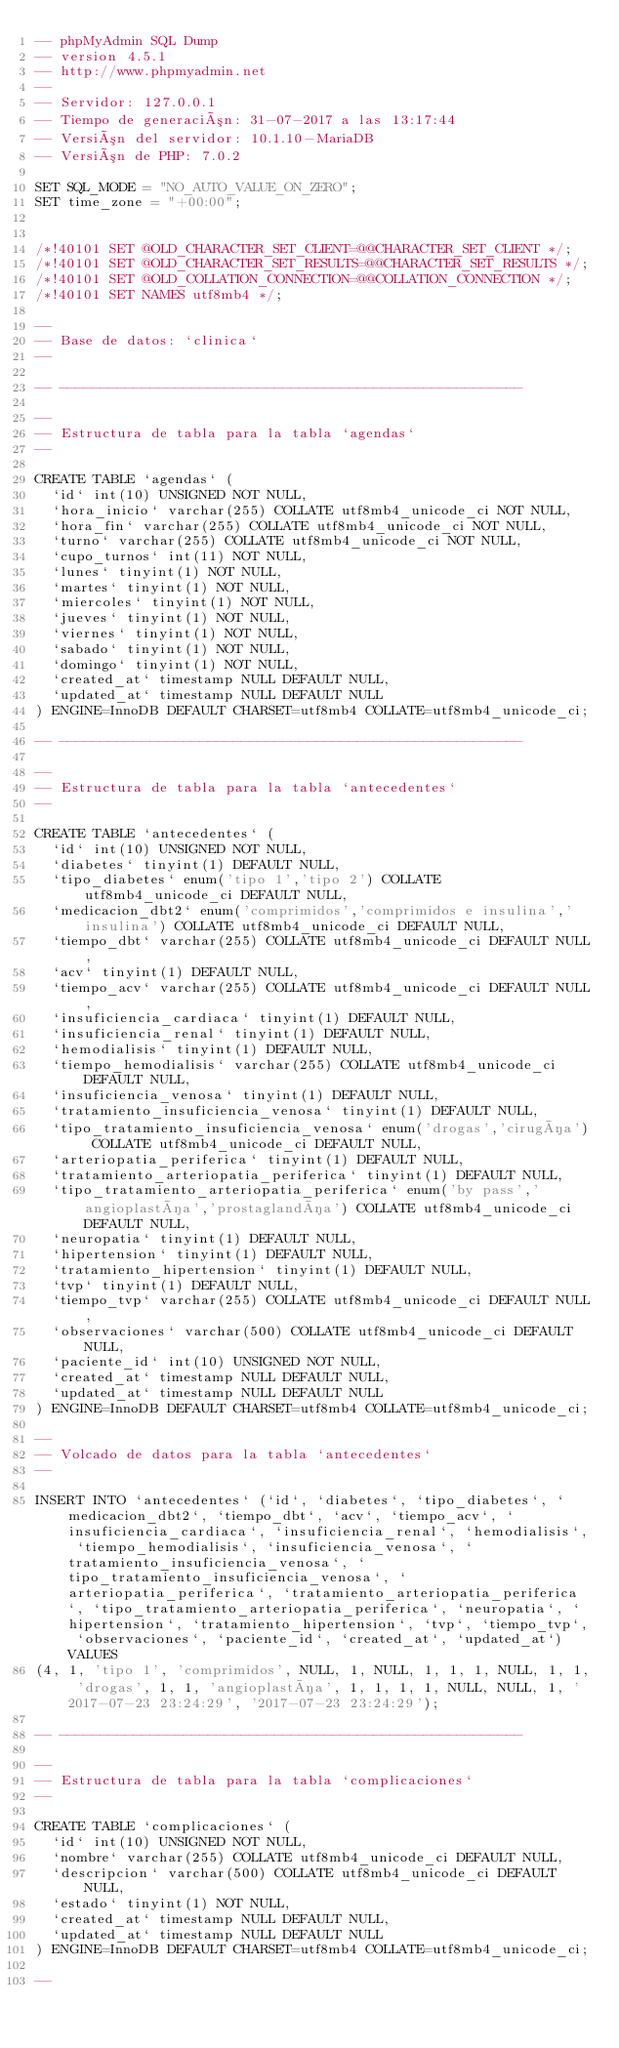Convert code to text. <code><loc_0><loc_0><loc_500><loc_500><_SQL_>-- phpMyAdmin SQL Dump
-- version 4.5.1
-- http://www.phpmyadmin.net
--
-- Servidor: 127.0.0.1
-- Tiempo de generación: 31-07-2017 a las 13:17:44
-- Versión del servidor: 10.1.10-MariaDB
-- Versión de PHP: 7.0.2

SET SQL_MODE = "NO_AUTO_VALUE_ON_ZERO";
SET time_zone = "+00:00";


/*!40101 SET @OLD_CHARACTER_SET_CLIENT=@@CHARACTER_SET_CLIENT */;
/*!40101 SET @OLD_CHARACTER_SET_RESULTS=@@CHARACTER_SET_RESULTS */;
/*!40101 SET @OLD_COLLATION_CONNECTION=@@COLLATION_CONNECTION */;
/*!40101 SET NAMES utf8mb4 */;

--
-- Base de datos: `clinica`
--

-- --------------------------------------------------------

--
-- Estructura de tabla para la tabla `agendas`
--

CREATE TABLE `agendas` (
  `id` int(10) UNSIGNED NOT NULL,
  `hora_inicio` varchar(255) COLLATE utf8mb4_unicode_ci NOT NULL,
  `hora_fin` varchar(255) COLLATE utf8mb4_unicode_ci NOT NULL,
  `turno` varchar(255) COLLATE utf8mb4_unicode_ci NOT NULL,
  `cupo_turnos` int(11) NOT NULL,
  `lunes` tinyint(1) NOT NULL,
  `martes` tinyint(1) NOT NULL,
  `miercoles` tinyint(1) NOT NULL,
  `jueves` tinyint(1) NOT NULL,
  `viernes` tinyint(1) NOT NULL,
  `sabado` tinyint(1) NOT NULL,
  `domingo` tinyint(1) NOT NULL,
  `created_at` timestamp NULL DEFAULT NULL,
  `updated_at` timestamp NULL DEFAULT NULL
) ENGINE=InnoDB DEFAULT CHARSET=utf8mb4 COLLATE=utf8mb4_unicode_ci;

-- --------------------------------------------------------

--
-- Estructura de tabla para la tabla `antecedentes`
--

CREATE TABLE `antecedentes` (
  `id` int(10) UNSIGNED NOT NULL,
  `diabetes` tinyint(1) DEFAULT NULL,
  `tipo_diabetes` enum('tipo 1','tipo 2') COLLATE utf8mb4_unicode_ci DEFAULT NULL,
  `medicacion_dbt2` enum('comprimidos','comprimidos e insulina','insulina') COLLATE utf8mb4_unicode_ci DEFAULT NULL,
  `tiempo_dbt` varchar(255) COLLATE utf8mb4_unicode_ci DEFAULT NULL,
  `acv` tinyint(1) DEFAULT NULL,
  `tiempo_acv` varchar(255) COLLATE utf8mb4_unicode_ci DEFAULT NULL,
  `insuficiencia_cardiaca` tinyint(1) DEFAULT NULL,
  `insuficiencia_renal` tinyint(1) DEFAULT NULL,
  `hemodialisis` tinyint(1) DEFAULT NULL,
  `tiempo_hemodialisis` varchar(255) COLLATE utf8mb4_unicode_ci DEFAULT NULL,
  `insuficiencia_venosa` tinyint(1) DEFAULT NULL,
  `tratamiento_insuficiencia_venosa` tinyint(1) DEFAULT NULL,
  `tipo_tratamiento_insuficiencia_venosa` enum('drogas','cirugía') COLLATE utf8mb4_unicode_ci DEFAULT NULL,
  `arteriopatia_periferica` tinyint(1) DEFAULT NULL,
  `tratamiento_arteriopatia_periferica` tinyint(1) DEFAULT NULL,
  `tipo_tratamiento_arteriopatia_periferica` enum('by pass','angioplastía','prostaglandía') COLLATE utf8mb4_unicode_ci DEFAULT NULL,
  `neuropatia` tinyint(1) DEFAULT NULL,
  `hipertension` tinyint(1) DEFAULT NULL,
  `tratamiento_hipertension` tinyint(1) DEFAULT NULL,
  `tvp` tinyint(1) DEFAULT NULL,
  `tiempo_tvp` varchar(255) COLLATE utf8mb4_unicode_ci DEFAULT NULL,
  `observaciones` varchar(500) COLLATE utf8mb4_unicode_ci DEFAULT NULL,
  `paciente_id` int(10) UNSIGNED NOT NULL,
  `created_at` timestamp NULL DEFAULT NULL,
  `updated_at` timestamp NULL DEFAULT NULL
) ENGINE=InnoDB DEFAULT CHARSET=utf8mb4 COLLATE=utf8mb4_unicode_ci;

--
-- Volcado de datos para la tabla `antecedentes`
--

INSERT INTO `antecedentes` (`id`, `diabetes`, `tipo_diabetes`, `medicacion_dbt2`, `tiempo_dbt`, `acv`, `tiempo_acv`, `insuficiencia_cardiaca`, `insuficiencia_renal`, `hemodialisis`, `tiempo_hemodialisis`, `insuficiencia_venosa`, `tratamiento_insuficiencia_venosa`, `tipo_tratamiento_insuficiencia_venosa`, `arteriopatia_periferica`, `tratamiento_arteriopatia_periferica`, `tipo_tratamiento_arteriopatia_periferica`, `neuropatia`, `hipertension`, `tratamiento_hipertension`, `tvp`, `tiempo_tvp`, `observaciones`, `paciente_id`, `created_at`, `updated_at`) VALUES
(4, 1, 'tipo 1', 'comprimidos', NULL, 1, NULL, 1, 1, 1, NULL, 1, 1, 'drogas', 1, 1, 'angioplastía', 1, 1, 1, 1, NULL, NULL, 1, '2017-07-23 23:24:29', '2017-07-23 23:24:29');

-- --------------------------------------------------------

--
-- Estructura de tabla para la tabla `complicaciones`
--

CREATE TABLE `complicaciones` (
  `id` int(10) UNSIGNED NOT NULL,
  `nombre` varchar(255) COLLATE utf8mb4_unicode_ci DEFAULT NULL,
  `descripcion` varchar(500) COLLATE utf8mb4_unicode_ci DEFAULT NULL,
  `estado` tinyint(1) NOT NULL,
  `created_at` timestamp NULL DEFAULT NULL,
  `updated_at` timestamp NULL DEFAULT NULL
) ENGINE=InnoDB DEFAULT CHARSET=utf8mb4 COLLATE=utf8mb4_unicode_ci;

--</code> 